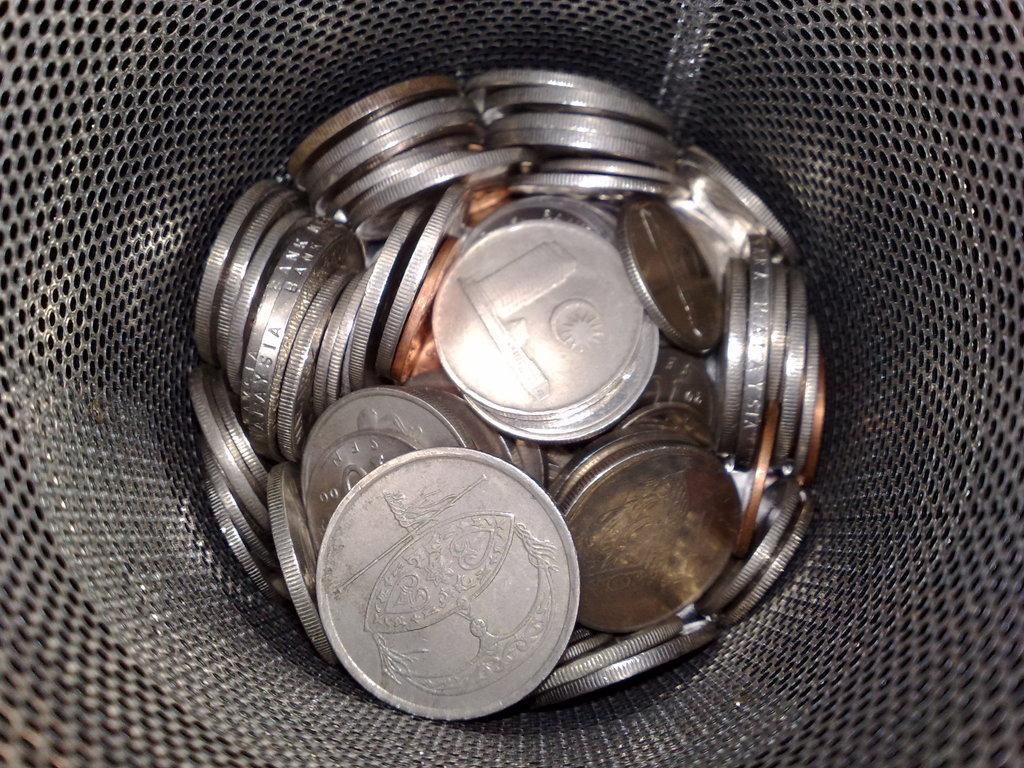How would you summarize this image in a sentence or two? There are coins in a container which is having a mesh. And the background is dark in color. 